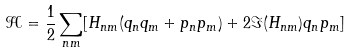<formula> <loc_0><loc_0><loc_500><loc_500>\mathcal { H } = \frac { 1 } { 2 } \sum _ { n m } [ H _ { n m } ( q _ { n } q _ { m } + p _ { n } p _ { m } ) + 2 \Im ( H _ { n m } ) q _ { n } p _ { m } ]</formula> 